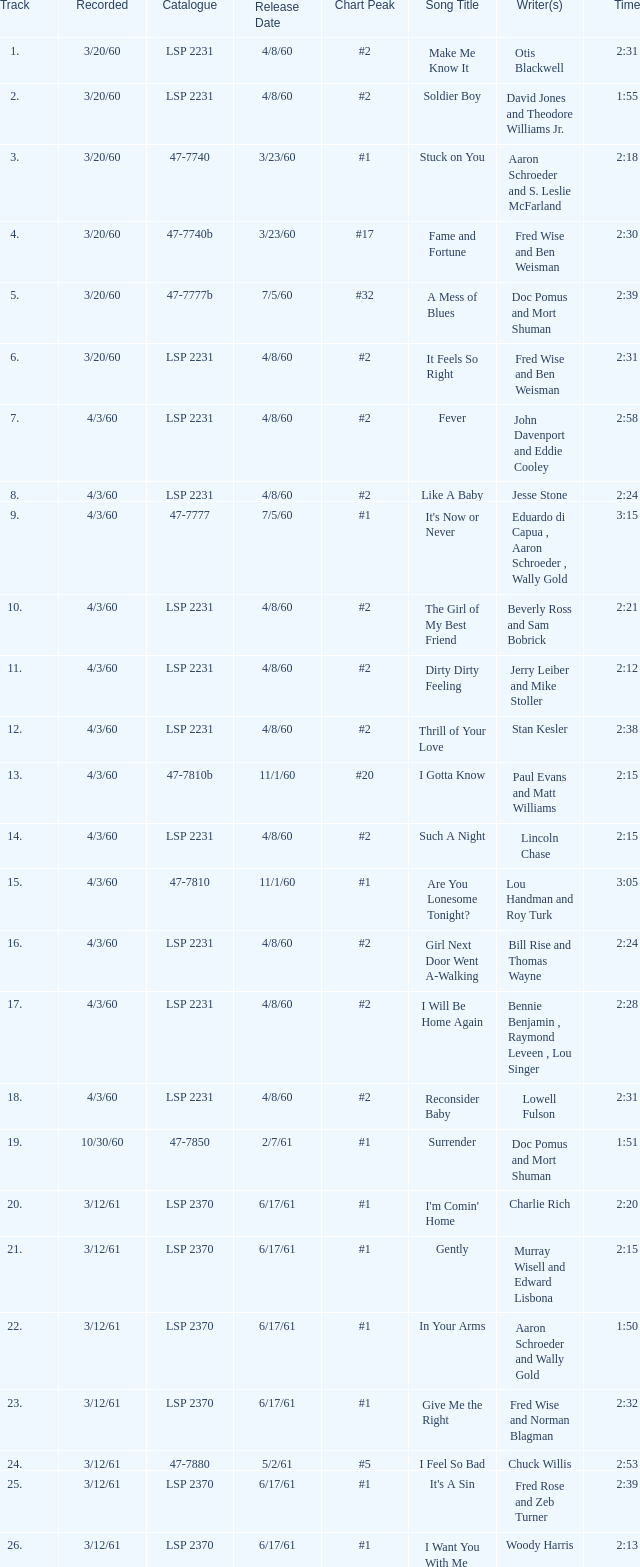What is the time of songs that have the writer Aaron Schroeder and Wally Gold? 1:50. 